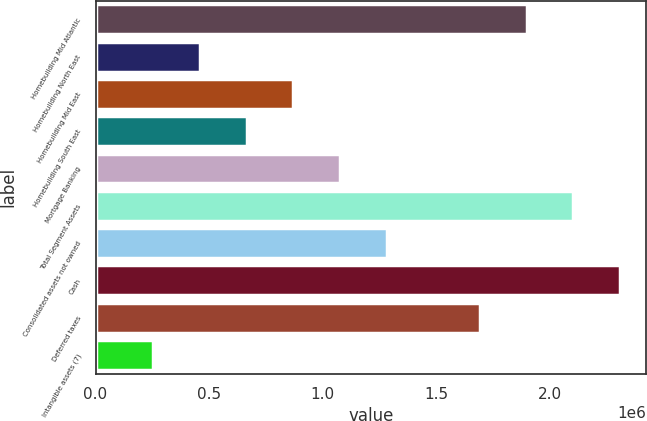Convert chart. <chart><loc_0><loc_0><loc_500><loc_500><bar_chart><fcel>Homebuilding Mid Atlantic<fcel>Homebuilding North East<fcel>Homebuilding Mid East<fcel>Homebuilding South East<fcel>Mortgage Banking<fcel>Total Segment Assets<fcel>Consolidated assets not owned<fcel>Cash<fcel>Deferred taxes<fcel>Intangible assets (7)<nl><fcel>1.89771e+06<fcel>459006<fcel>870064<fcel>664535<fcel>1.07559e+06<fcel>2.10324e+06<fcel>1.28112e+06<fcel>2.30876e+06<fcel>1.69218e+06<fcel>253478<nl></chart> 